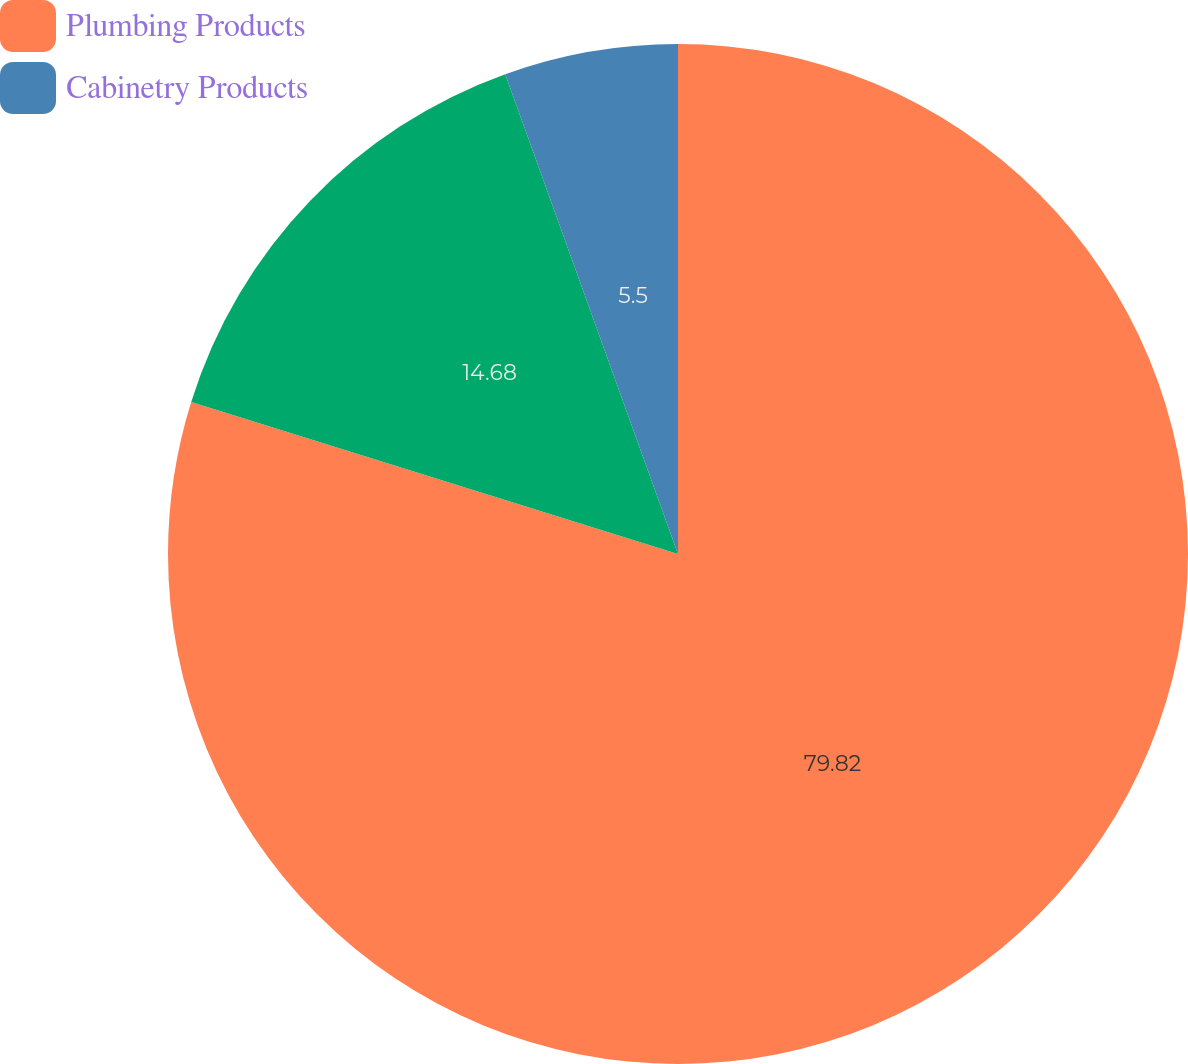<chart> <loc_0><loc_0><loc_500><loc_500><pie_chart><fcel>Plumbing Products<fcel>Unnamed: 1<fcel>Cabinetry Products<nl><fcel>79.82%<fcel>14.68%<fcel>5.5%<nl></chart> 